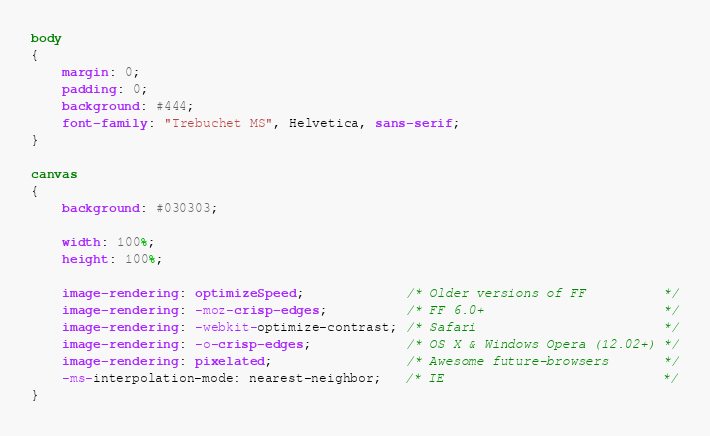Convert code to text. <code><loc_0><loc_0><loc_500><loc_500><_CSS_>body
{
	margin: 0;
	padding: 0;
	background: #444;
	font-family: "Trebuchet MS", Helvetica, sans-serif;
}

canvas
{
	background: #030303;

	width: 100%;
	height: 100%;

	image-rendering: optimizeSpeed;             /* Older versions of FF          */
	image-rendering: -moz-crisp-edges;          /* FF 6.0+                       */
	image-rendering: -webkit-optimize-contrast; /* Safari                        */
	image-rendering: -o-crisp-edges;            /* OS X & Windows Opera (12.02+) */
	image-rendering: pixelated;                 /* Awesome future-browsers       */
	-ms-interpolation-mode: nearest-neighbor;   /* IE                            */
}</code> 